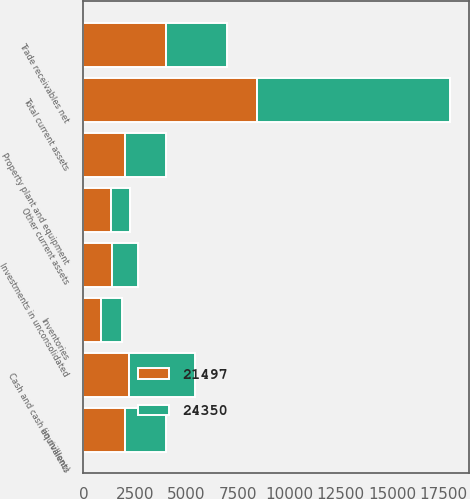Convert chart to OTSL. <chart><loc_0><loc_0><loc_500><loc_500><stacked_bar_chart><ecel><fcel>(in millions)<fcel>Cash and cash equivalents<fcel>Trade receivables net<fcel>Inventories<fcel>Other current assets<fcel>Total current assets<fcel>Investments in unconsolidated<fcel>Property plant and equipment<nl><fcel>21497<fcel>2016<fcel>2233<fcel>3989<fcel>866<fcel>1340<fcel>8428<fcel>1401<fcel>2015.5<nl><fcel>24350<fcel>2015<fcel>3201<fcel>2970<fcel>986<fcel>911<fcel>9402<fcel>1267<fcel>2015.5<nl></chart> 